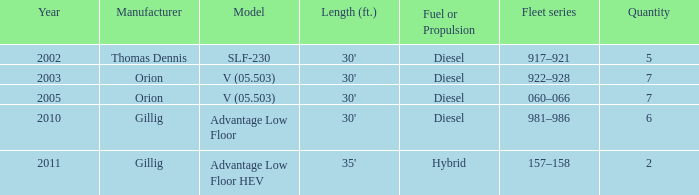Tell me the model with fuel or propulsion of diesel and orion manufacturer in 2005 V (05.503). 